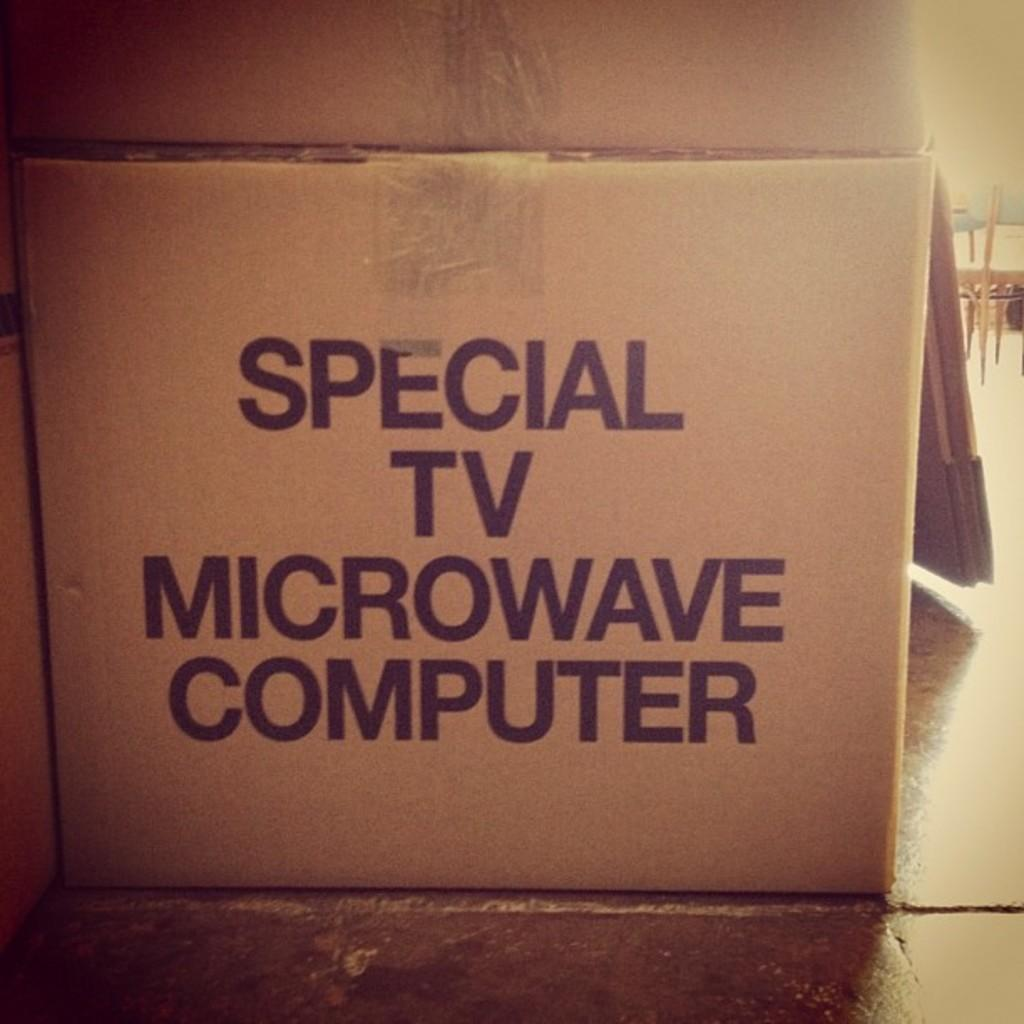<image>
Share a concise interpretation of the image provided. A carboard box that could be used to contain special items such as a computer. 